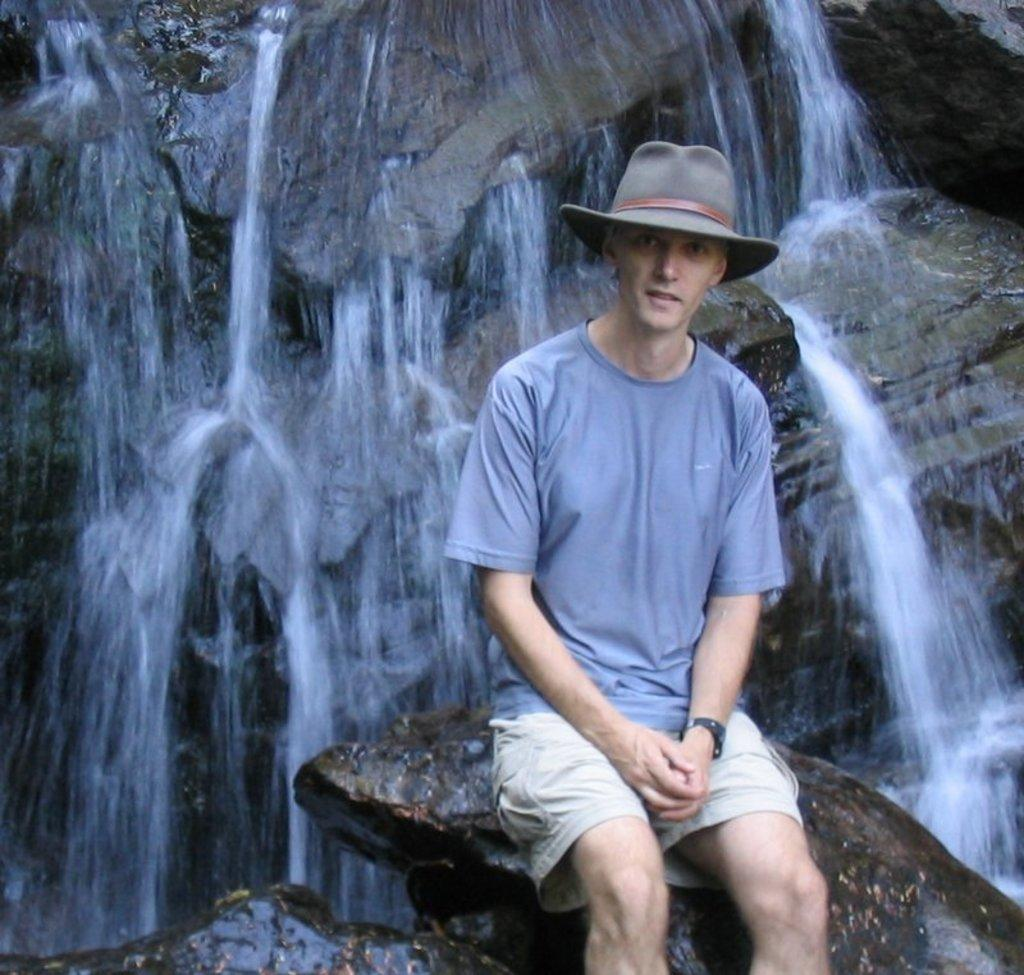What is the man in the image doing? The man is sitting on a rock in the image. What accessories is the man wearing? The man is wearing a hat and a watch. What can be seen in the background of the image? There are mountains and a waterfall visible in the background of the image. Where is the crow sitting in the image? There is no crow present in the image. What type of shop can be seen in the background of the image? There is no shop visible in the image; it features a man sitting on a rock, mountains, and a waterfall in the background. 